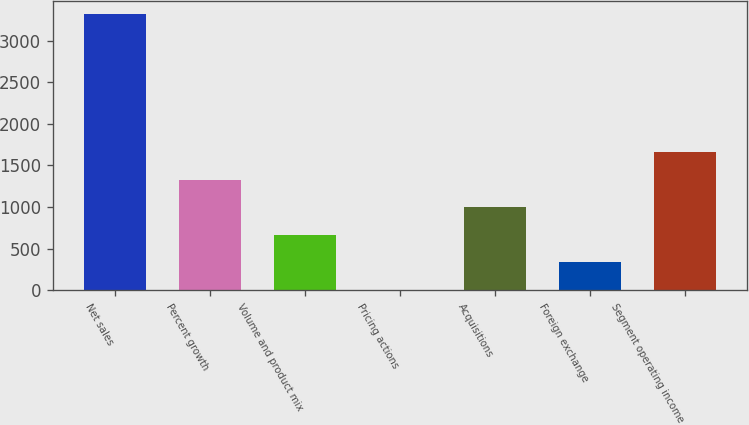Convert chart. <chart><loc_0><loc_0><loc_500><loc_500><bar_chart><fcel>Net sales<fcel>Percent growth<fcel>Volume and product mix<fcel>Pricing actions<fcel>Acquisitions<fcel>Foreign exchange<fcel>Segment operating income<nl><fcel>3318<fcel>1327.56<fcel>664.08<fcel>0.6<fcel>995.82<fcel>332.34<fcel>1659.3<nl></chart> 